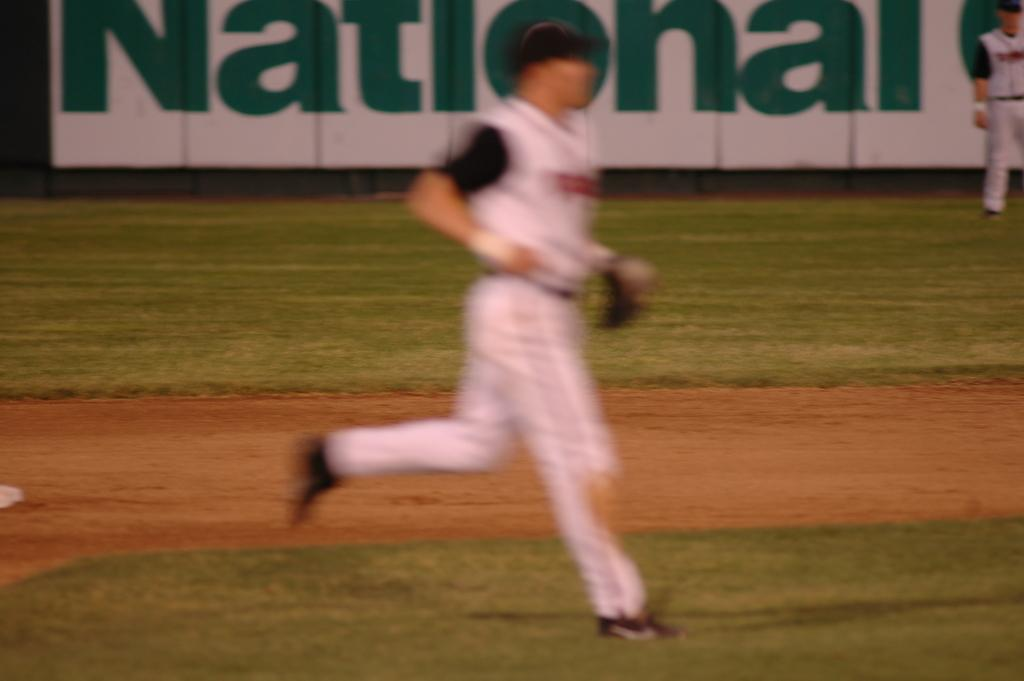Provide a one-sentence caption for the provided image. A baseball player running on the field with National advertising behind him. 